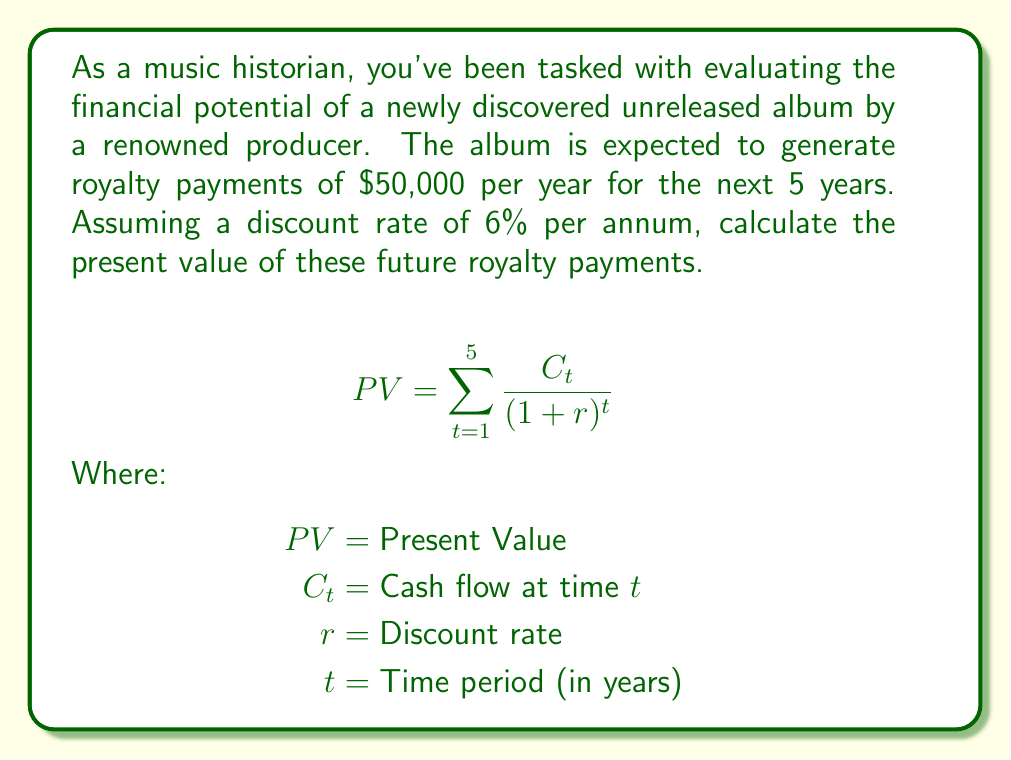Help me with this question. To calculate the present value of future royalty payments, we'll use the present value formula for a series of cash flows:

$$PV = \sum_{t=1}^{5} \frac{C_t}{(1+r)^t}$$

Given:
- Annual royalty payment ($C_t$) = $50,000
- Discount rate ($r$) = 6% = 0.06
- Time periods ($t$) = 5 years

Let's calculate the present value for each year:

Year 1: $\frac{50,000}{(1+0.06)^1} = \frac{50,000}{1.06} = 47,169.81$

Year 2: $\frac{50,000}{(1+0.06)^2} = \frac{50,000}{1.1236} = 44,499.82$

Year 3: $\frac{50,000}{(1+0.06)^3} = \frac{50,000}{1.191016} = 41,980.96$

Year 4: $\frac{50,000}{(1+0.06)^4} = \frac{50,000}{1.262477} = 39,604.68$

Year 5: $\frac{50,000}{(1+0.06)^5} = \frac{50,000}{1.338226} = 37,362.91$

Now, we sum up all these present values:

$PV = 47,169.81 + 44,499.82 + 41,980.96 + 39,604.68 + 37,362.91 = 210,618.18$

Therefore, the present value of the future royalty payments is $210,618.18.
Answer: $210,618.18 